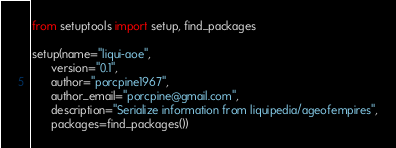<code> <loc_0><loc_0><loc_500><loc_500><_Python_>from setuptools import setup, find_packages

setup(name="liqui-aoe",
      version="0.1",
      author="porcpine1967",
      author_email="porcpine@gmail.com",
      description="Serialize information from liquipedia/ageofempires",
      packages=find_packages())

</code> 